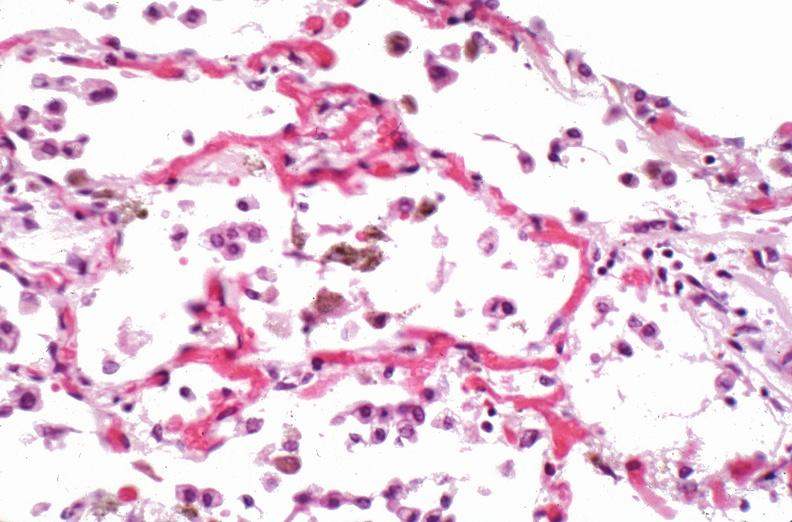how does this image show lung, pneumonia and hemosiderin laden macrophages in patient?
Answer the question using a single word or phrase. With sickle cell disease iatrogenic hemosiderosis 